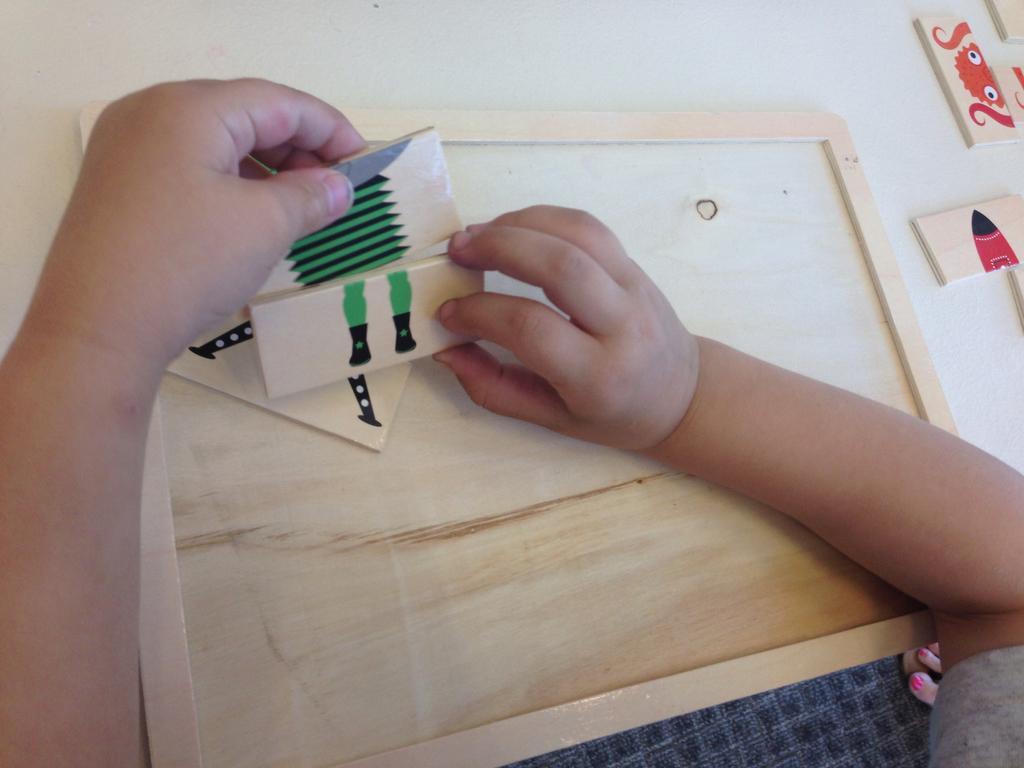Please provide a concise description of this image. In the center of the image we can see the hands of a person is holding one object. And we can see one table. On the table, we can see some objects. On the right side of the image, we can see toes on the dark colored object. 